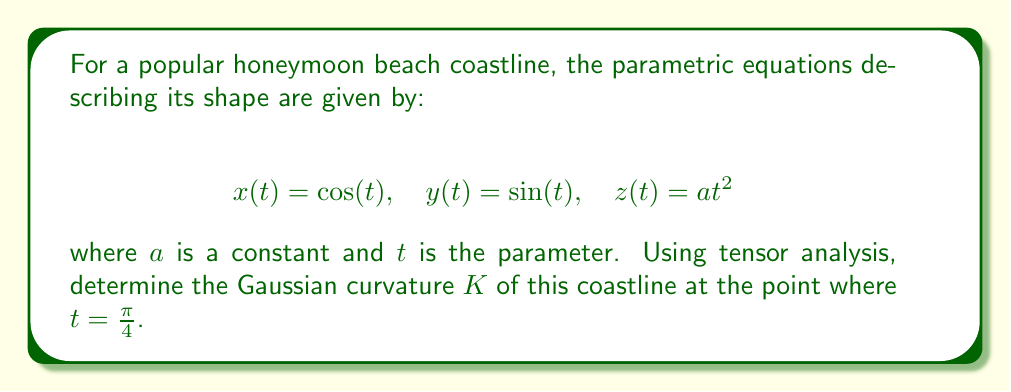Solve this math problem. To find the Gaussian curvature using tensor analysis, we'll follow these steps:

1) First, we need to compute the metric tensor $g_{ij}$:
   $$g_{11} = \left(\frac{dx}{dt}\right)^2 + \left(\frac{dy}{dt}\right)^2 + \left(\frac{dz}{dt}\right)^2$$
   $$\frac{dx}{dt} = -\sin(t), \quad \frac{dy}{dt} = \cos(t), \quad \frac{dz}{dt} = 2at$$
   $$g_{11} = \sin^2(t) + \cos^2(t) + 4a^2t^2 = 1 + 4a^2t^2$$

2) Now, we need to compute the second fundamental form coefficients:
   $$L = \frac{d^2x}{dt^2}\cdot \mathbf{n}, \quad M = \frac{d^2y}{dt^2}\cdot \mathbf{n}, \quad N = \frac{d^2z}{dt^2}\cdot \mathbf{n}$$
   where $\mathbf{n}$ is the unit normal vector.

3) The unit normal vector is given by:
   $$\mathbf{n} = \frac{\frac{d\mathbf{r}}{dt} \times \frac{d^2\mathbf{r}}{dt^2}}{\left|\frac{d\mathbf{r}}{dt} \times \frac{d^2\mathbf{r}}{dt^2}\right|}$$
   
   After calculation, we get:
   $$\mathbf{n} = \frac{(-2at\cos(t), -2at\sin(t), 1)}{\sqrt{1 + 4a^2t^2}}$$

4) Now we can compute $L$, $M$, and $N$:
   $$L = \frac{-\cos(t)}{\sqrt{1 + 4a^2t^2}}, \quad M = \frac{-\sin(t)}{\sqrt{1 + 4a^2t^2}}, \quad N = \frac{2a}{\sqrt{1 + 4a^2t^2}}$$

5) The Gaussian curvature is given by:
   $$K = \frac{LN - M^2}{g_{11}}$$

6) Substituting $t = \frac{\pi}{4}$:
   $$K = \frac{(-\frac{\cos(\pi/4)}{\sqrt{1 + a^2\pi^2/4}})(\frac{2a}{\sqrt{1 + a^2\pi^2/4}}) - (-\frac{\sin(\pi/4)}{\sqrt{1 + a^2\pi^2/4}})^2}{1 + a^2\pi^2/4}$$

7) Simplifying:
   $$K = \frac{-\sqrt{2}a - 1/2}{(1 + a^2\pi^2/4)^2}$$
Answer: $$K = \frac{-\sqrt{2}a - 1/2}{(1 + a^2\pi^2/4)^2}$$ 